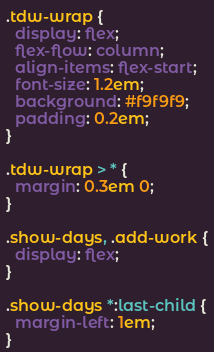Convert code to text. <code><loc_0><loc_0><loc_500><loc_500><_CSS_>.tdw-wrap {
  display: flex;
  flex-flow: column;
  align-items: flex-start;
  font-size: 1.2em;
  background: #f9f9f9;
  padding: 0.2em;
}

.tdw-wrap > * {
  margin: 0.3em 0;
}

.show-days, .add-work {
  display: flex;
}

.show-days *:last-child {
  margin-left: 1em;
}
</code> 